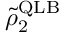Convert formula to latex. <formula><loc_0><loc_0><loc_500><loc_500>\tilde { \rho } _ { 2 } ^ { Q L B }</formula> 